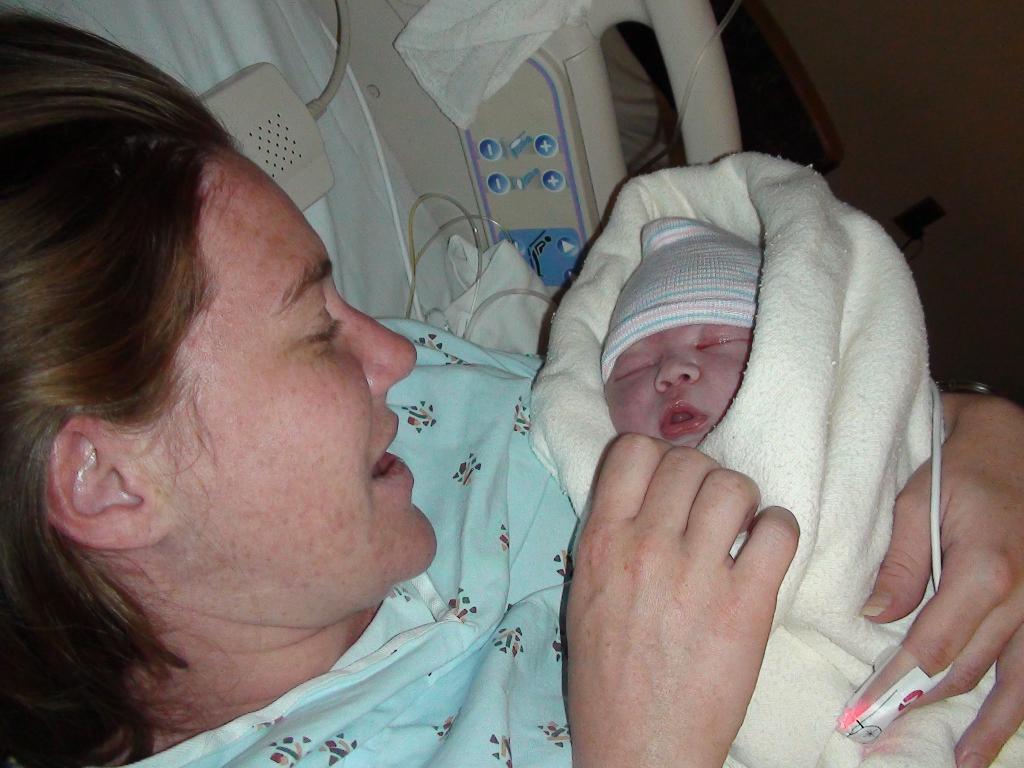Could you give a brief overview of what you see in this image? In this image we can see the person holding baby with cloth and at the back we can see a curtain, cloth and a few objects. And right side, we can see the wall. 